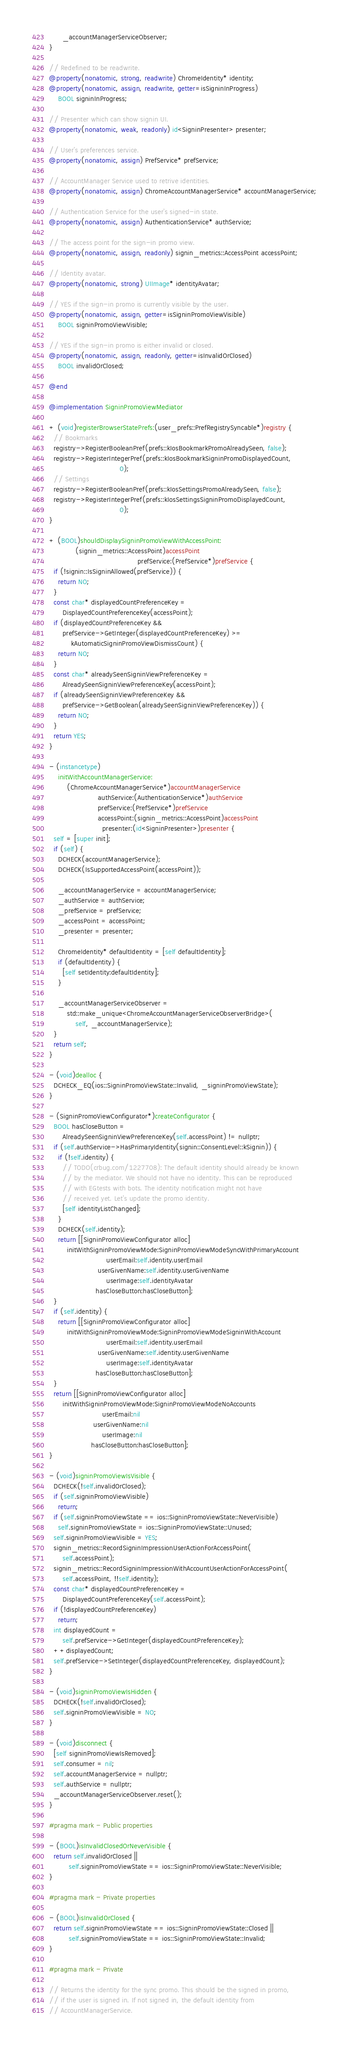Convert code to text. <code><loc_0><loc_0><loc_500><loc_500><_ObjectiveC_>      _accountManagerServiceObserver;
}

// Redefined to be readwrite.
@property(nonatomic, strong, readwrite) ChromeIdentity* identity;
@property(nonatomic, assign, readwrite, getter=isSigninInProgress)
    BOOL signinInProgress;

// Presenter which can show signin UI.
@property(nonatomic, weak, readonly) id<SigninPresenter> presenter;

// User's preferences service.
@property(nonatomic, assign) PrefService* prefService;

// AccountManager Service used to retrive identities.
@property(nonatomic, assign) ChromeAccountManagerService* accountManagerService;

// Authentication Service for the user's signed-in state.
@property(nonatomic, assign) AuthenticationService* authService;

// The access point for the sign-in promo view.
@property(nonatomic, assign, readonly) signin_metrics::AccessPoint accessPoint;

// Identity avatar.
@property(nonatomic, strong) UIImage* identityAvatar;

// YES if the sign-in promo is currently visible by the user.
@property(nonatomic, assign, getter=isSigninPromoViewVisible)
    BOOL signinPromoViewVisible;

// YES if the sign-in promo is either invalid or closed.
@property(nonatomic, assign, readonly, getter=isInvalidOrClosed)
    BOOL invalidOrClosed;

@end

@implementation SigninPromoViewMediator

+ (void)registerBrowserStatePrefs:(user_prefs::PrefRegistrySyncable*)registry {
  // Bookmarks
  registry->RegisterBooleanPref(prefs::kIosBookmarkPromoAlreadySeen, false);
  registry->RegisterIntegerPref(prefs::kIosBookmarkSigninPromoDisplayedCount,
                                0);
  // Settings
  registry->RegisterBooleanPref(prefs::kIosSettingsPromoAlreadySeen, false);
  registry->RegisterIntegerPref(prefs::kIosSettingsSigninPromoDisplayedCount,
                                0);
}

+ (BOOL)shouldDisplaySigninPromoViewWithAccessPoint:
            (signin_metrics::AccessPoint)accessPoint
                                        prefService:(PrefService*)prefService {
  if (!signin::IsSigninAllowed(prefService)) {
    return NO;
  }
  const char* displayedCountPreferenceKey =
      DisplayedCountPreferenceKey(accessPoint);
  if (displayedCountPreferenceKey &&
      prefService->GetInteger(displayedCountPreferenceKey) >=
          kAutomaticSigninPromoViewDismissCount) {
    return NO;
  }
  const char* alreadySeenSigninViewPreferenceKey =
      AlreadySeenSigninViewPreferenceKey(accessPoint);
  if (alreadySeenSigninViewPreferenceKey &&
      prefService->GetBoolean(alreadySeenSigninViewPreferenceKey)) {
    return NO;
  }
  return YES;
}

- (instancetype)
    initWithAccountManagerService:
        (ChromeAccountManagerService*)accountManagerService
                      authService:(AuthenticationService*)authService
                      prefService:(PrefService*)prefService
                      accessPoint:(signin_metrics::AccessPoint)accessPoint
                        presenter:(id<SigninPresenter>)presenter {
  self = [super init];
  if (self) {
    DCHECK(accountManagerService);
    DCHECK(IsSupportedAccessPoint(accessPoint));

    _accountManagerService = accountManagerService;
    _authService = authService;
    _prefService = prefService;
    _accessPoint = accessPoint;
    _presenter = presenter;

    ChromeIdentity* defaultIdentity = [self defaultIdentity];
    if (defaultIdentity) {
      [self setIdentity:defaultIdentity];
    }

    _accountManagerServiceObserver =
        std::make_unique<ChromeAccountManagerServiceObserverBridge>(
            self, _accountManagerService);
  }
  return self;
}

- (void)dealloc {
  DCHECK_EQ(ios::SigninPromoViewState::Invalid, _signinPromoViewState);
}

- (SigninPromoViewConfigurator*)createConfigurator {
  BOOL hasCloseButton =
      AlreadySeenSigninViewPreferenceKey(self.accessPoint) != nullptr;
  if (self.authService->HasPrimaryIdentity(signin::ConsentLevel::kSignin)) {
    if (!self.identity) {
      // TODO(crbug.com/1227708): The default identity should already be known
      // by the mediator. We should not have no identity. This can be reproduced
      // with EGtests with bots. The identity notification might not have
      // received yet. Let's update the promo identity.
      [self identityListChanged];
    }
    DCHECK(self.identity);
    return [[SigninPromoViewConfigurator alloc]
        initWithSigninPromoViewMode:SigninPromoViewModeSyncWithPrimaryAccount
                          userEmail:self.identity.userEmail
                      userGivenName:self.identity.userGivenName
                          userImage:self.identityAvatar
                     hasCloseButton:hasCloseButton];
  }
  if (self.identity) {
    return [[SigninPromoViewConfigurator alloc]
        initWithSigninPromoViewMode:SigninPromoViewModeSigninWithAccount
                          userEmail:self.identity.userEmail
                      userGivenName:self.identity.userGivenName
                          userImage:self.identityAvatar
                     hasCloseButton:hasCloseButton];
  }
  return [[SigninPromoViewConfigurator alloc]
      initWithSigninPromoViewMode:SigninPromoViewModeNoAccounts
                        userEmail:nil
                    userGivenName:nil
                        userImage:nil
                   hasCloseButton:hasCloseButton];
}

- (void)signinPromoViewIsVisible {
  DCHECK(!self.invalidOrClosed);
  if (self.signinPromoViewVisible)
    return;
  if (self.signinPromoViewState == ios::SigninPromoViewState::NeverVisible)
    self.signinPromoViewState = ios::SigninPromoViewState::Unused;
  self.signinPromoViewVisible = YES;
  signin_metrics::RecordSigninImpressionUserActionForAccessPoint(
      self.accessPoint);
  signin_metrics::RecordSigninImpressionWithAccountUserActionForAccessPoint(
      self.accessPoint, !!self.identity);
  const char* displayedCountPreferenceKey =
      DisplayedCountPreferenceKey(self.accessPoint);
  if (!displayedCountPreferenceKey)
    return;
  int displayedCount =
      self.prefService->GetInteger(displayedCountPreferenceKey);
  ++displayedCount;
  self.prefService->SetInteger(displayedCountPreferenceKey, displayedCount);
}

- (void)signinPromoViewIsHidden {
  DCHECK(!self.invalidOrClosed);
  self.signinPromoViewVisible = NO;
}

- (void)disconnect {
  [self signinPromoViewIsRemoved];
  self.consumer = nil;
  self.accountManagerService = nullptr;
  self.authService = nullptr;
  _accountManagerServiceObserver.reset();
}

#pragma mark - Public properties

- (BOOL)isInvalidClosedOrNeverVisible {
  return self.invalidOrClosed ||
         self.signinPromoViewState == ios::SigninPromoViewState::NeverVisible;
}

#pragma mark - Private properties

- (BOOL)isInvalidOrClosed {
  return self.signinPromoViewState == ios::SigninPromoViewState::Closed ||
         self.signinPromoViewState == ios::SigninPromoViewState::Invalid;
}

#pragma mark - Private

// Returns the identity for the sync promo. This should be the signed in promo,
// if the user is signed in. If not signed in, the default identity from
// AccountManagerService.</code> 